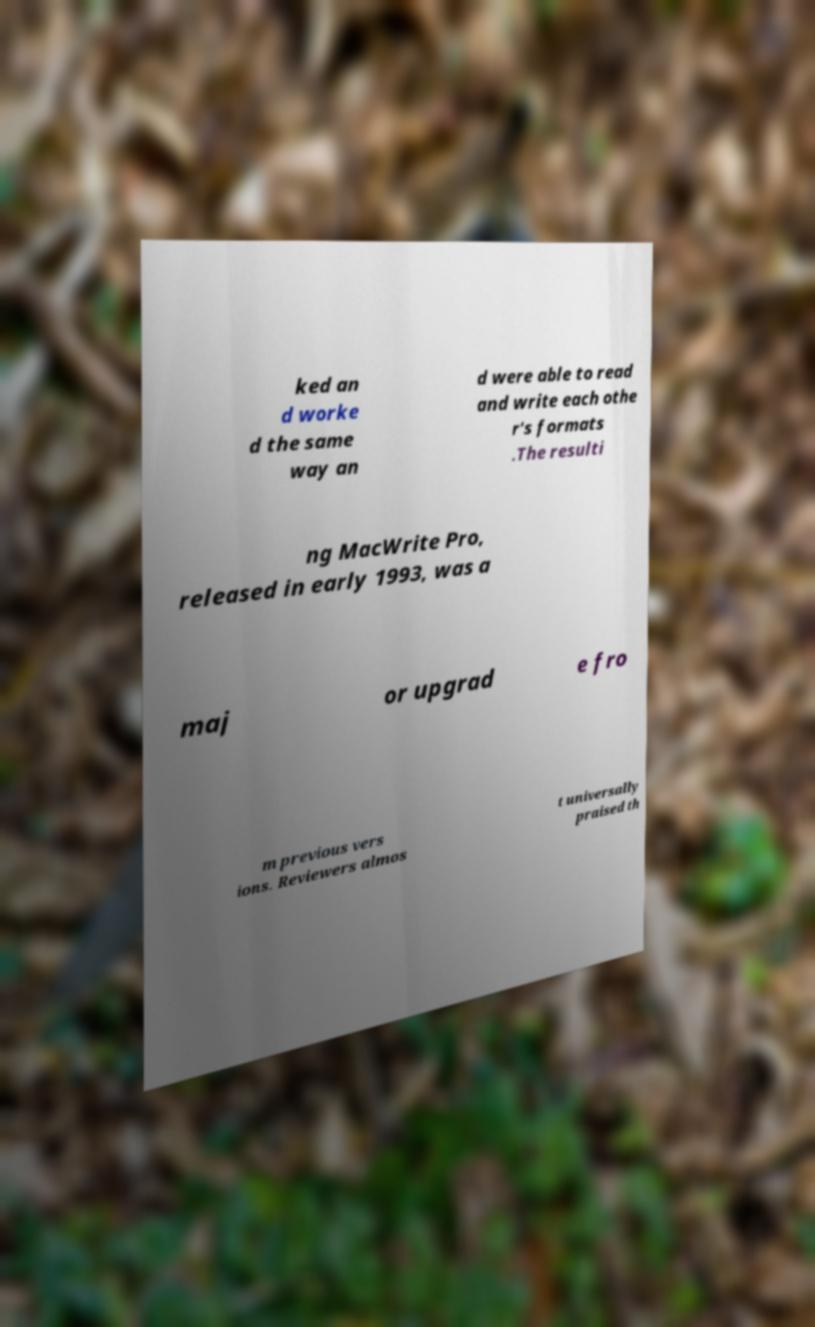Can you accurately transcribe the text from the provided image for me? ked an d worke d the same way an d were able to read and write each othe r's formats .The resulti ng MacWrite Pro, released in early 1993, was a maj or upgrad e fro m previous vers ions. Reviewers almos t universally praised th 